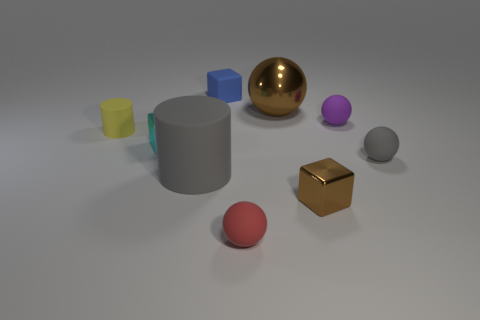Are the brown thing behind the tiny yellow rubber object and the gray sphere made of the same material?
Provide a short and direct response. No. What shape is the small red rubber thing?
Make the answer very short. Sphere. Are there more big brown things in front of the blue rubber cube than tiny gray metallic cubes?
Your response must be concise. Yes. Is there anything else that has the same shape as the tiny brown object?
Your answer should be compact. Yes. There is another shiny thing that is the same shape as the small gray object; what color is it?
Keep it short and to the point. Brown. What shape is the gray rubber thing on the right side of the purple rubber object?
Ensure brevity in your answer.  Sphere. There is a tiny yellow rubber cylinder; are there any yellow cylinders behind it?
Offer a terse response. No. Is there anything else that has the same size as the gray cylinder?
Offer a terse response. Yes. What is the color of the tiny cylinder that is the same material as the small red sphere?
Offer a terse response. Yellow. Do the matte ball that is left of the small brown shiny block and the small matte sphere that is behind the tiny yellow cylinder have the same color?
Offer a terse response. No. 